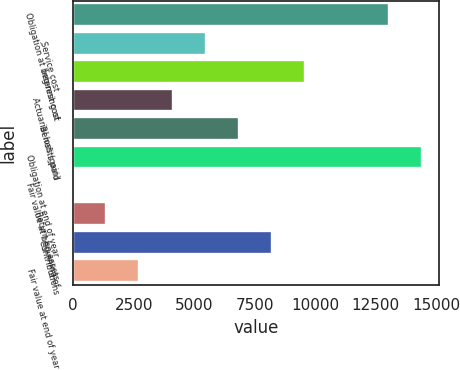<chart> <loc_0><loc_0><loc_500><loc_500><bar_chart><fcel>Obligation at beginning of<fcel>Service cost<fcel>Interest cost<fcel>Actuarial loss (gain)<fcel>Benefits paid<fcel>Obligation at end of year<fcel>Fair value at beginning of<fcel>Return on assets<fcel>Contributions<fcel>Fair value at end of year<nl><fcel>13040<fcel>5472.1<fcel>9576.04<fcel>4104.12<fcel>6840.08<fcel>14408<fcel>0.18<fcel>1368.16<fcel>8208.06<fcel>2736.14<nl></chart> 